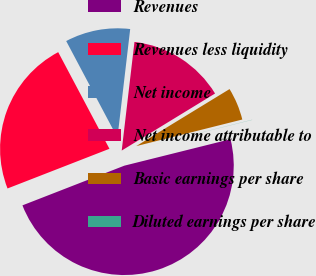<chart> <loc_0><loc_0><loc_500><loc_500><pie_chart><fcel>Revenues<fcel>Revenues less liquidity<fcel>Net income<fcel>Net income attributable to<fcel>Basic earnings per share<fcel>Diluted earnings per share<nl><fcel>47.98%<fcel>23.15%<fcel>9.62%<fcel>14.41%<fcel>4.82%<fcel>0.02%<nl></chart> 